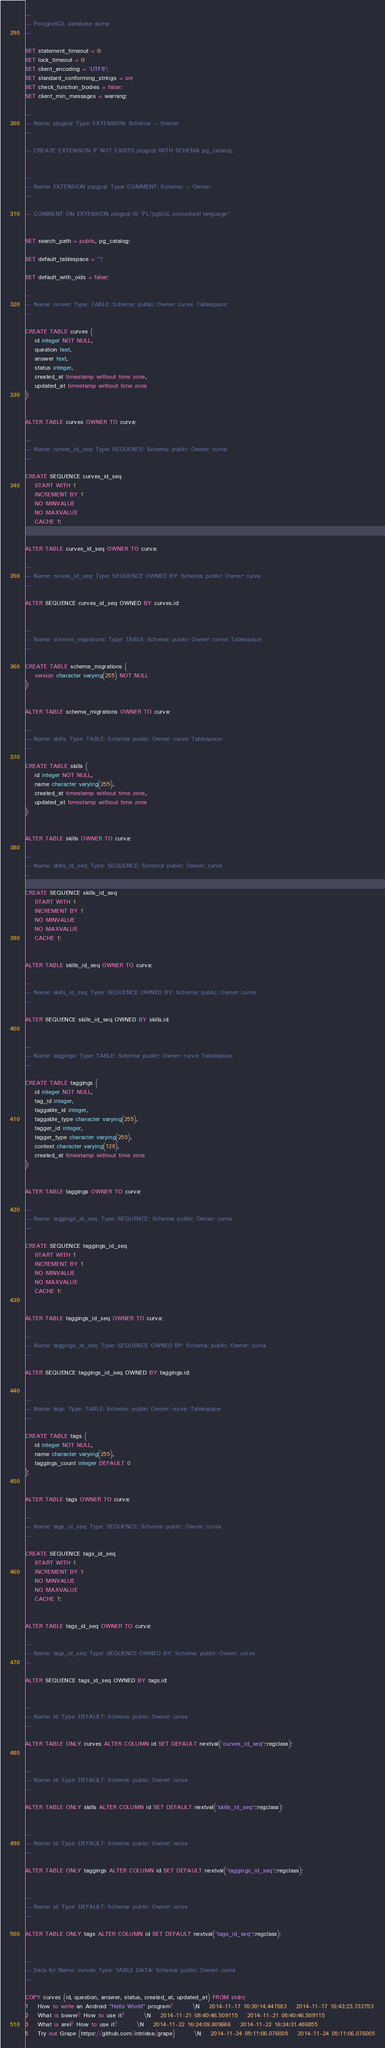<code> <loc_0><loc_0><loc_500><loc_500><_SQL_>--
-- PostgreSQL database dump
--

SET statement_timeout = 0;
SET lock_timeout = 0;
SET client_encoding = 'UTF8';
SET standard_conforming_strings = on;
SET check_function_bodies = false;
SET client_min_messages = warning;

--
-- Name: plpgsql; Type: EXTENSION; Schema: -; Owner: 
--

-- CREATE EXTENSION IF NOT EXISTS plpgsql WITH SCHEMA pg_catalog;


--
-- Name: EXTENSION plpgsql; Type: COMMENT; Schema: -; Owner: 
--

-- COMMENT ON EXTENSION plpgsql IS 'PL/pgSQL procedural language';


SET search_path = public, pg_catalog;

SET default_tablespace = '';

SET default_with_oids = false;

--
-- Name: curves; Type: TABLE; Schema: public; Owner: curva; Tablespace: 
--

CREATE TABLE curves (
    id integer NOT NULL,
    question text,
    answer text,
    status integer,
    created_at timestamp without time zone,
    updated_at timestamp without time zone
);


ALTER TABLE curves OWNER TO curva;

--
-- Name: curves_id_seq; Type: SEQUENCE; Schema: public; Owner: curva
--

CREATE SEQUENCE curves_id_seq
    START WITH 1
    INCREMENT BY 1
    NO MINVALUE
    NO MAXVALUE
    CACHE 1;


ALTER TABLE curves_id_seq OWNER TO curva;

--
-- Name: curves_id_seq; Type: SEQUENCE OWNED BY; Schema: public; Owner: curva
--

ALTER SEQUENCE curves_id_seq OWNED BY curves.id;


--
-- Name: schema_migrations; Type: TABLE; Schema: public; Owner: curva; Tablespace: 
--

CREATE TABLE schema_migrations (
    version character varying(255) NOT NULL
);


ALTER TABLE schema_migrations OWNER TO curva;

--
-- Name: skills; Type: TABLE; Schema: public; Owner: curva; Tablespace: 
--

CREATE TABLE skills (
    id integer NOT NULL,
    name character varying(255),
    created_at timestamp without time zone,
    updated_at timestamp without time zone
);


ALTER TABLE skills OWNER TO curva;

--
-- Name: skills_id_seq; Type: SEQUENCE; Schema: public; Owner: curva
--

CREATE SEQUENCE skills_id_seq
    START WITH 1
    INCREMENT BY 1
    NO MINVALUE
    NO MAXVALUE
    CACHE 1;


ALTER TABLE skills_id_seq OWNER TO curva;

--
-- Name: skills_id_seq; Type: SEQUENCE OWNED BY; Schema: public; Owner: curva
--

ALTER SEQUENCE skills_id_seq OWNED BY skills.id;


--
-- Name: taggings; Type: TABLE; Schema: public; Owner: curva; Tablespace: 
--

CREATE TABLE taggings (
    id integer NOT NULL,
    tag_id integer,
    taggable_id integer,
    taggable_type character varying(255),
    tagger_id integer,
    tagger_type character varying(255),
    context character varying(128),
    created_at timestamp without time zone
);


ALTER TABLE taggings OWNER TO curva;

--
-- Name: taggings_id_seq; Type: SEQUENCE; Schema: public; Owner: curva
--

CREATE SEQUENCE taggings_id_seq
    START WITH 1
    INCREMENT BY 1
    NO MINVALUE
    NO MAXVALUE
    CACHE 1;


ALTER TABLE taggings_id_seq OWNER TO curva;

--
-- Name: taggings_id_seq; Type: SEQUENCE OWNED BY; Schema: public; Owner: curva
--

ALTER SEQUENCE taggings_id_seq OWNED BY taggings.id;


--
-- Name: tags; Type: TABLE; Schema: public; Owner: curva; Tablespace: 
--

CREATE TABLE tags (
    id integer NOT NULL,
    name character varying(255),
    taggings_count integer DEFAULT 0
);


ALTER TABLE tags OWNER TO curva;

--
-- Name: tags_id_seq; Type: SEQUENCE; Schema: public; Owner: curva
--

CREATE SEQUENCE tags_id_seq
    START WITH 1
    INCREMENT BY 1
    NO MINVALUE
    NO MAXVALUE
    CACHE 1;


ALTER TABLE tags_id_seq OWNER TO curva;

--
-- Name: tags_id_seq; Type: SEQUENCE OWNED BY; Schema: public; Owner: curva
--

ALTER SEQUENCE tags_id_seq OWNED BY tags.id;


--
-- Name: id; Type: DEFAULT; Schema: public; Owner: curva
--

ALTER TABLE ONLY curves ALTER COLUMN id SET DEFAULT nextval('curves_id_seq'::regclass);


--
-- Name: id; Type: DEFAULT; Schema: public; Owner: curva
--

ALTER TABLE ONLY skills ALTER COLUMN id SET DEFAULT nextval('skills_id_seq'::regclass);


--
-- Name: id; Type: DEFAULT; Schema: public; Owner: curva
--

ALTER TABLE ONLY taggings ALTER COLUMN id SET DEFAULT nextval('taggings_id_seq'::regclass);


--
-- Name: id; Type: DEFAULT; Schema: public; Owner: curva
--

ALTER TABLE ONLY tags ALTER COLUMN id SET DEFAULT nextval('tags_id_seq'::regclass);


--
-- Data for Name: curves; Type: TABLE DATA; Schema: public; Owner: curva
--

COPY curves (id, question, answer, status, created_at, updated_at) FROM stdin;
1	How to write an Android "Hello World" program?		\N	2014-11-17 16:30:14.441583	2014-11-17 16:43:23.732753
2	What is bower? How to use it?		\N	2014-11-21 08:40:46.509115	2014-11-21 08:40:46.509115
3	What is arel? How to use it?		\N	2014-11-22 16:24:09.809666	2014-11-22 16:24:31.486855
5	Try out Grape (https://github.com/intridea/grape)		\N	2014-11-24 05:11:06.076005	2014-11-24 05:11:06.076005</code> 